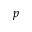Convert formula to latex. <formula><loc_0><loc_0><loc_500><loc_500>p</formula> 